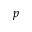Convert formula to latex. <formula><loc_0><loc_0><loc_500><loc_500>p</formula> 